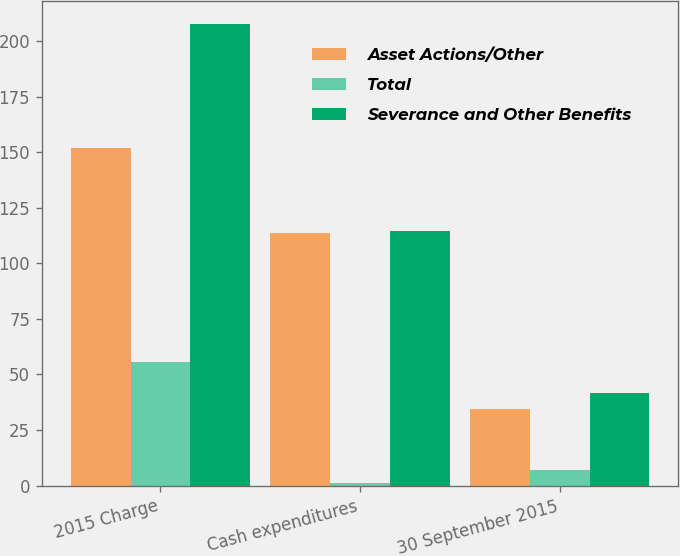Convert chart to OTSL. <chart><loc_0><loc_0><loc_500><loc_500><stacked_bar_chart><ecel><fcel>2015 Charge<fcel>Cash expenditures<fcel>30 September 2015<nl><fcel>Asset Actions/Other<fcel>151.9<fcel>113.5<fcel>34.5<nl><fcel>Total<fcel>55.8<fcel>1.2<fcel>7.2<nl><fcel>Severance and Other Benefits<fcel>207.7<fcel>114.7<fcel>41.7<nl></chart> 